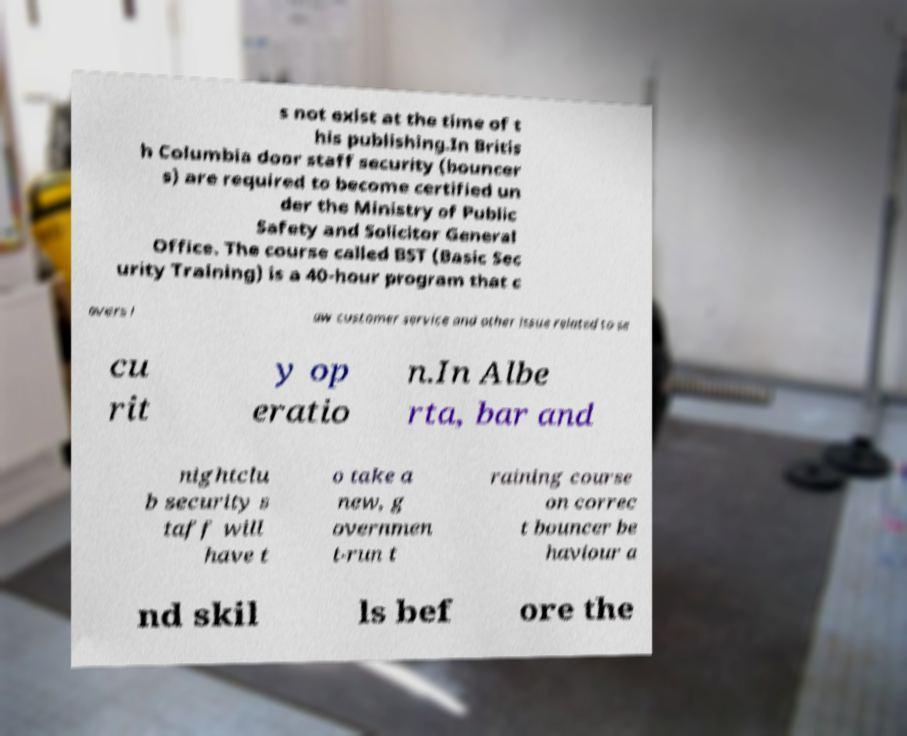Could you assist in decoding the text presented in this image and type it out clearly? s not exist at the time of t his publishing.In Britis h Columbia door staff security (bouncer s) are required to become certified un der the Ministry of Public Safety and Solicitor General Office. The course called BST (Basic Sec urity Training) is a 40-hour program that c overs l aw customer service and other issue related to se cu rit y op eratio n.In Albe rta, bar and nightclu b security s taff will have t o take a new, g overnmen t-run t raining course on correc t bouncer be haviour a nd skil ls bef ore the 